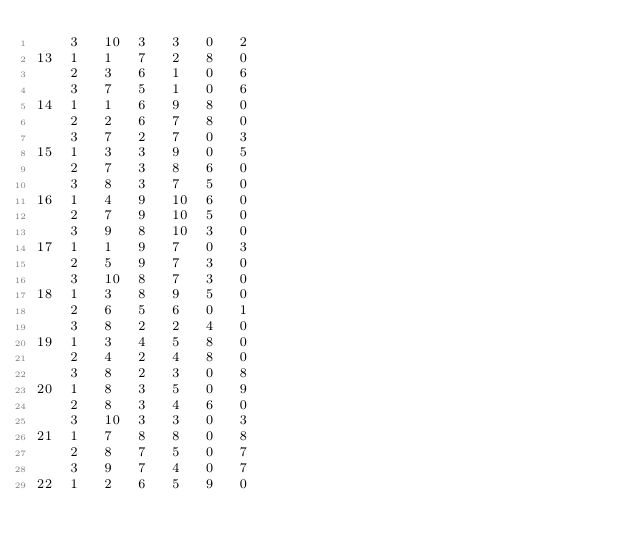<code> <loc_0><loc_0><loc_500><loc_500><_ObjectiveC_>	3	10	3	3	0	2	
13	1	1	7	2	8	0	
	2	3	6	1	0	6	
	3	7	5	1	0	6	
14	1	1	6	9	8	0	
	2	2	6	7	8	0	
	3	7	2	7	0	3	
15	1	3	3	9	0	5	
	2	7	3	8	6	0	
	3	8	3	7	5	0	
16	1	4	9	10	6	0	
	2	7	9	10	5	0	
	3	9	8	10	3	0	
17	1	1	9	7	0	3	
	2	5	9	7	3	0	
	3	10	8	7	3	0	
18	1	3	8	9	5	0	
	2	6	5	6	0	1	
	3	8	2	2	4	0	
19	1	3	4	5	8	0	
	2	4	2	4	8	0	
	3	8	2	3	0	8	
20	1	8	3	5	0	9	
	2	8	3	4	6	0	
	3	10	3	3	0	3	
21	1	7	8	8	0	8	
	2	8	7	5	0	7	
	3	9	7	4	0	7	
22	1	2	6	5	9	0	</code> 